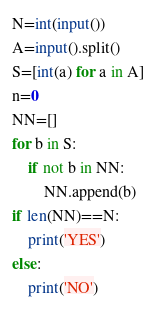<code> <loc_0><loc_0><loc_500><loc_500><_Python_>N=int(input())
A=input().split()
S=[int(a) for a in A]
n=0
NN=[]
for b in S:
    if not b in NN:
        NN.append(b)
if len(NN)==N:
    print('YES')
else:
    print('NO')
    </code> 